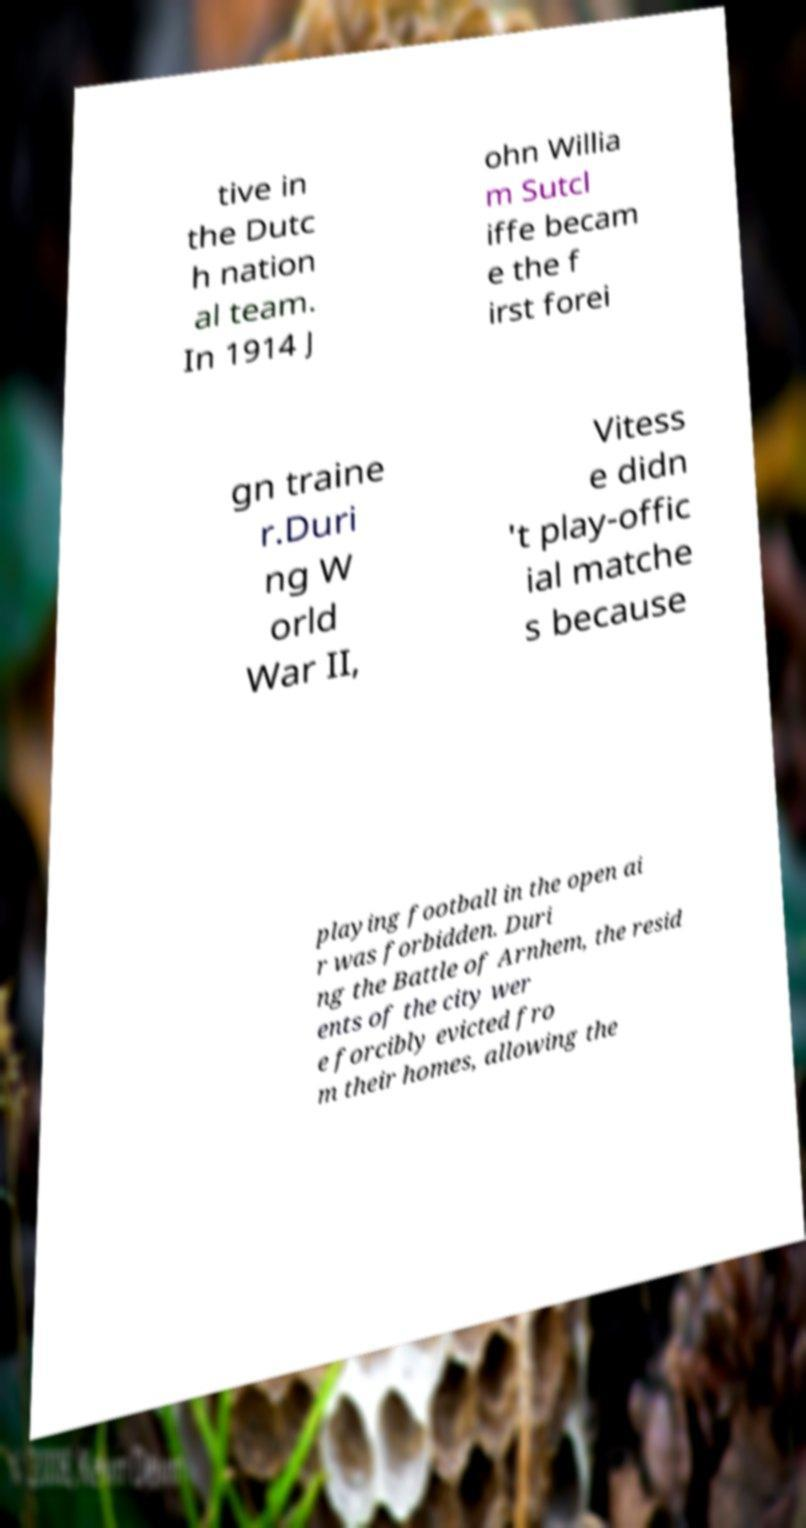Can you read and provide the text displayed in the image?This photo seems to have some interesting text. Can you extract and type it out for me? tive in the Dutc h nation al team. In 1914 J ohn Willia m Sutcl iffe becam e the f irst forei gn traine r.Duri ng W orld War II, Vitess e didn 't play-offic ial matche s because playing football in the open ai r was forbidden. Duri ng the Battle of Arnhem, the resid ents of the city wer e forcibly evicted fro m their homes, allowing the 